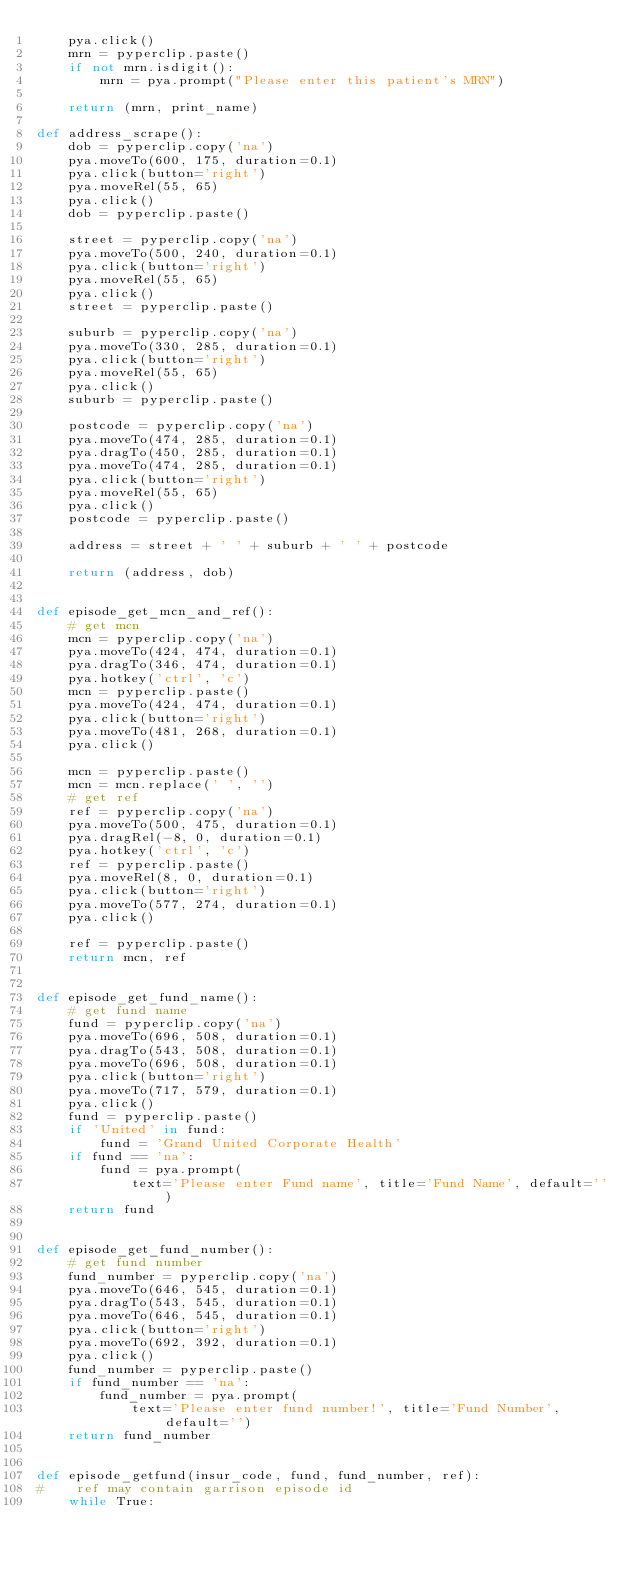<code> <loc_0><loc_0><loc_500><loc_500><_Python_>    pya.click()
    mrn = pyperclip.paste()
    if not mrn.isdigit():
        mrn = pya.prompt("Please enter this patient's MRN")
    
    return (mrn, print_name)
        
def address_scrape():
    dob = pyperclip.copy('na')
    pya.moveTo(600, 175, duration=0.1)
    pya.click(button='right')
    pya.moveRel(55, 65)
    pya.click()
    dob = pyperclip.paste()
    
    street = pyperclip.copy('na')
    pya.moveTo(500, 240, duration=0.1)
    pya.click(button='right')
    pya.moveRel(55, 65)
    pya.click()
    street = pyperclip.paste()
    
    suburb = pyperclip.copy('na')
    pya.moveTo(330, 285, duration=0.1)
    pya.click(button='right')
    pya.moveRel(55, 65)
    pya.click()
    suburb = pyperclip.paste()
    
    postcode = pyperclip.copy('na')
    pya.moveTo(474, 285, duration=0.1)
    pya.dragTo(450, 285, duration=0.1)
    pya.moveTo(474, 285, duration=0.1)
    pya.click(button='right')
    pya.moveRel(55, 65)
    pya.click()
    postcode = pyperclip.paste()

    address = street + ' ' + suburb + ' ' + postcode

    return (address, dob)


def episode_get_mcn_and_ref():
    # get mcn
    mcn = pyperclip.copy('na')
    pya.moveTo(424, 474, duration=0.1)
    pya.dragTo(346, 474, duration=0.1)
    pya.hotkey('ctrl', 'c')
    mcn = pyperclip.paste()
    pya.moveTo(424, 474, duration=0.1)
    pya.click(button='right')
    pya.moveTo(481, 268, duration=0.1)
    pya.click()
    
    mcn = pyperclip.paste()
    mcn = mcn.replace(' ', '')
    # get ref
    ref = pyperclip.copy('na')
    pya.moveTo(500, 475, duration=0.1)
    pya.dragRel(-8, 0, duration=0.1)
    pya.hotkey('ctrl', 'c')
    ref = pyperclip.paste()
    pya.moveRel(8, 0, duration=0.1)
    pya.click(button='right')
    pya.moveTo(577, 274, duration=0.1)
    pya.click()
    
    ref = pyperclip.paste()
    return mcn, ref


def episode_get_fund_name():
    # get fund name
    fund = pyperclip.copy('na')
    pya.moveTo(696, 508, duration=0.1)
    pya.dragTo(543, 508, duration=0.1)
    pya.moveTo(696, 508, duration=0.1)
    pya.click(button='right')
    pya.moveTo(717, 579, duration=0.1)
    pya.click()
    fund = pyperclip.paste()
    if 'United' in fund:
        fund = 'Grand United Corporate Health'
    if fund == 'na':
        fund = pya.prompt(
            text='Please enter Fund name', title='Fund Name', default='')
    return fund


def episode_get_fund_number():
    # get fund number
    fund_number = pyperclip.copy('na')
    pya.moveTo(646, 545, duration=0.1)
    pya.dragTo(543, 545, duration=0.1)
    pya.moveTo(646, 545, duration=0.1)
    pya.click(button='right')
    pya.moveTo(692, 392, duration=0.1)
    pya.click()
    fund_number = pyperclip.paste()
    if fund_number == 'na':
        fund_number = pya.prompt(
            text='Please enter fund number!', title='Fund Number', default='')
    return fund_number


def episode_getfund(insur_code, fund, fund_number, ref):
#    ref may contain garrison episode id
    while True:</code> 